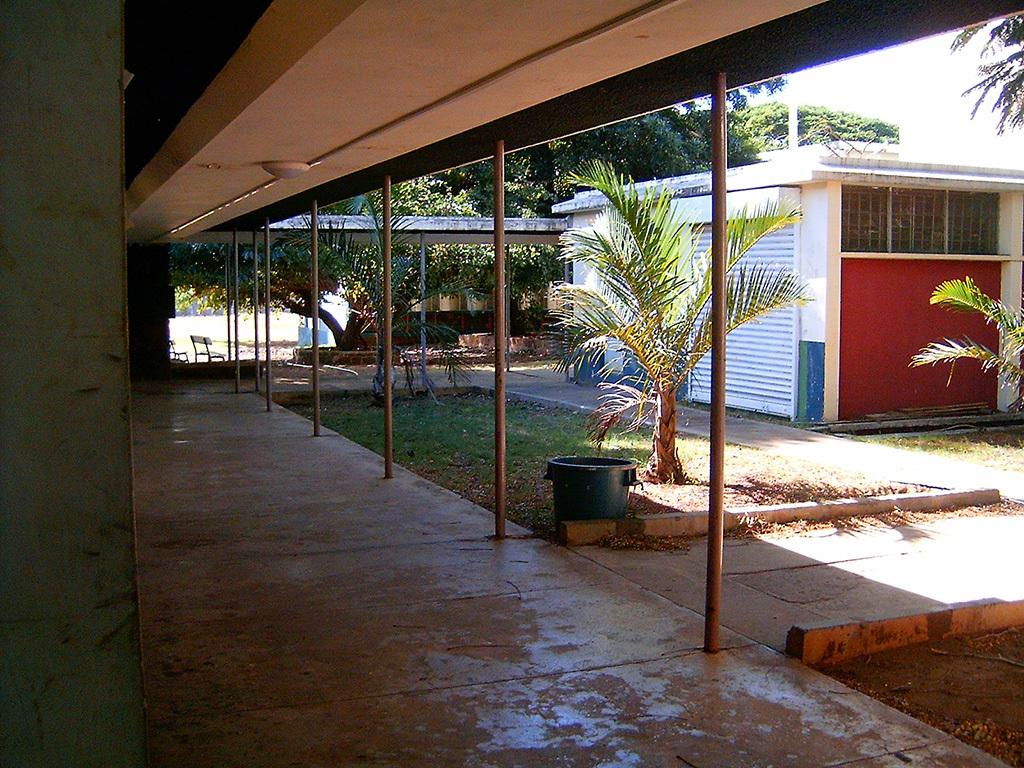What type of structures can be seen in the image? There are buildings and a shed in the image. What other objects are present in the image? There are poles, trees, chairs, and unspecified objects in the image. What can be seen in the sky in the image? The sky is visible in the image. Where is the veil located in the image? There is no veil present in the image. How many spiders can be seen on the chairs in the image? There are no spiders visible in the image. 